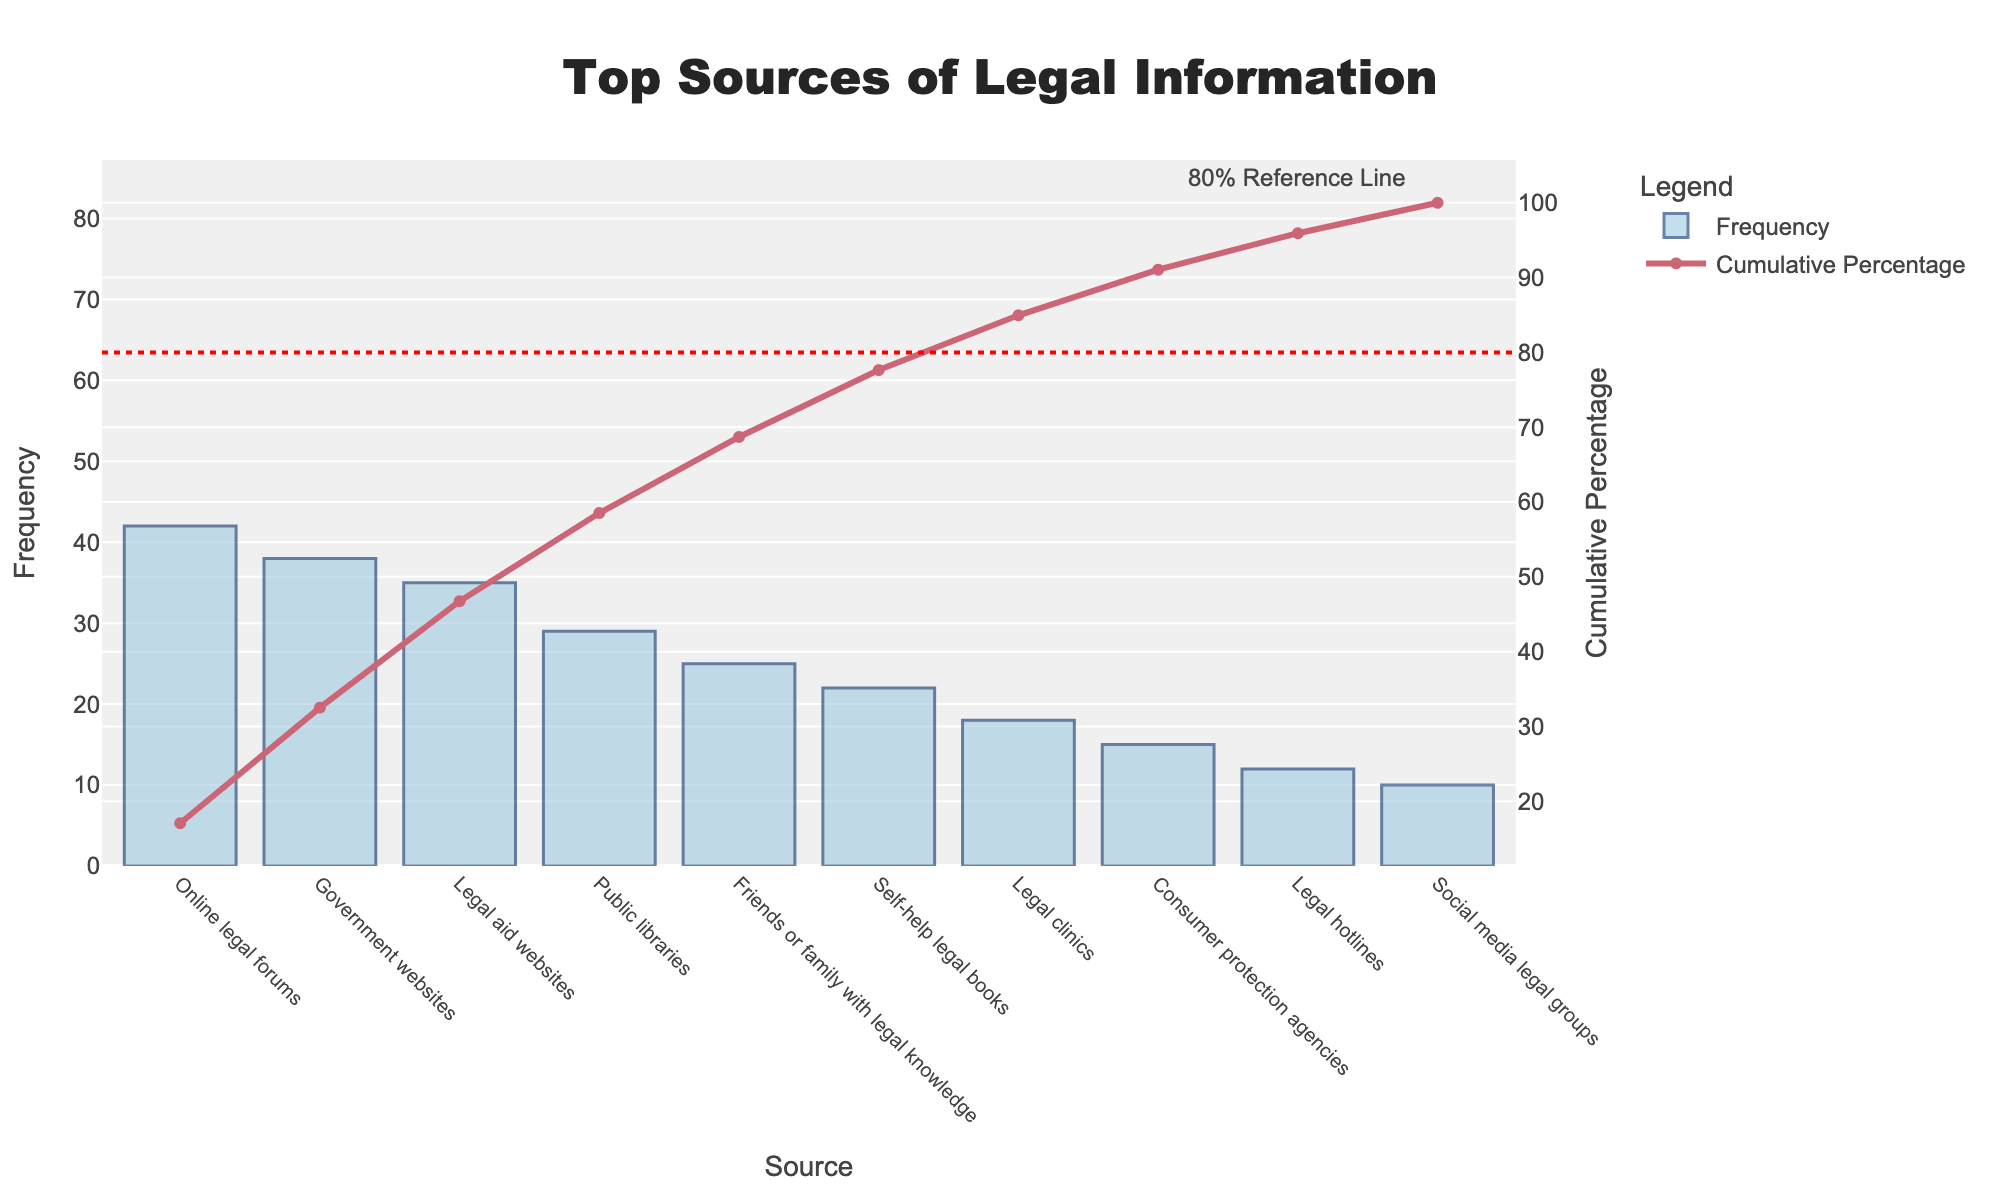What's the title of the chart? The title of the chart is prominently displayed at the top center.
Answer: Top Sources of Legal Information How many data sources are represented in the chart? Count the number of unique data points on the x-axis.
Answer: 10 Which source of legal information has the highest frequency? Look at the bar heights and identify the tallest one, then refer to its label on the x-axis.
Answer: Online legal forums What cumulative percentage is reached after considering the top three sources? Find the cumulative percentages for the top three sources: 42 + 38 + 35 = 115, then (115/246) * 100 = ~46.75%
Answer: Approximately 46.75% Which sources fall below the 80% cumulative percentage line? Identify the sources whose corresponding points on the cumulative percentage line fall below 80%.
Answer: All except Legal hotlines and Social media legal groups What's the combined frequency of Public libraries and Legal aid websites? Add the frequencies of these two sources: 29 + 35
Answer: 64 How does the frequency of Government websites compare to Legal clinics? Compare the heights of their respective bars: 38 for Government websites versus 18 for Legal clinics.
Answer: Government websites have a higher frequency What is the approximate cumulative percentage after the first six sources? Add up their frequencies and then calculate the cumulative percentage: (42 + 38 + 35 + 29 + 25 + 22) = 191, then (191/246) * 100 = ~77.6%
Answer: Approximately 77.6% Which source is the least consulted according to the chart? Look for the source with the shortest bar and its label on the x-axis.
Answer: Social media legal groups What is the significance of the 80% reference line in the chart? The 80% reference line helps indicate which sources cumulatively account for 80% of the total frequency. Those below the line collectively make up the bulk of consults, highlighting their importance.
Answer: It indicates the sources that contribute to the majority of consultations 